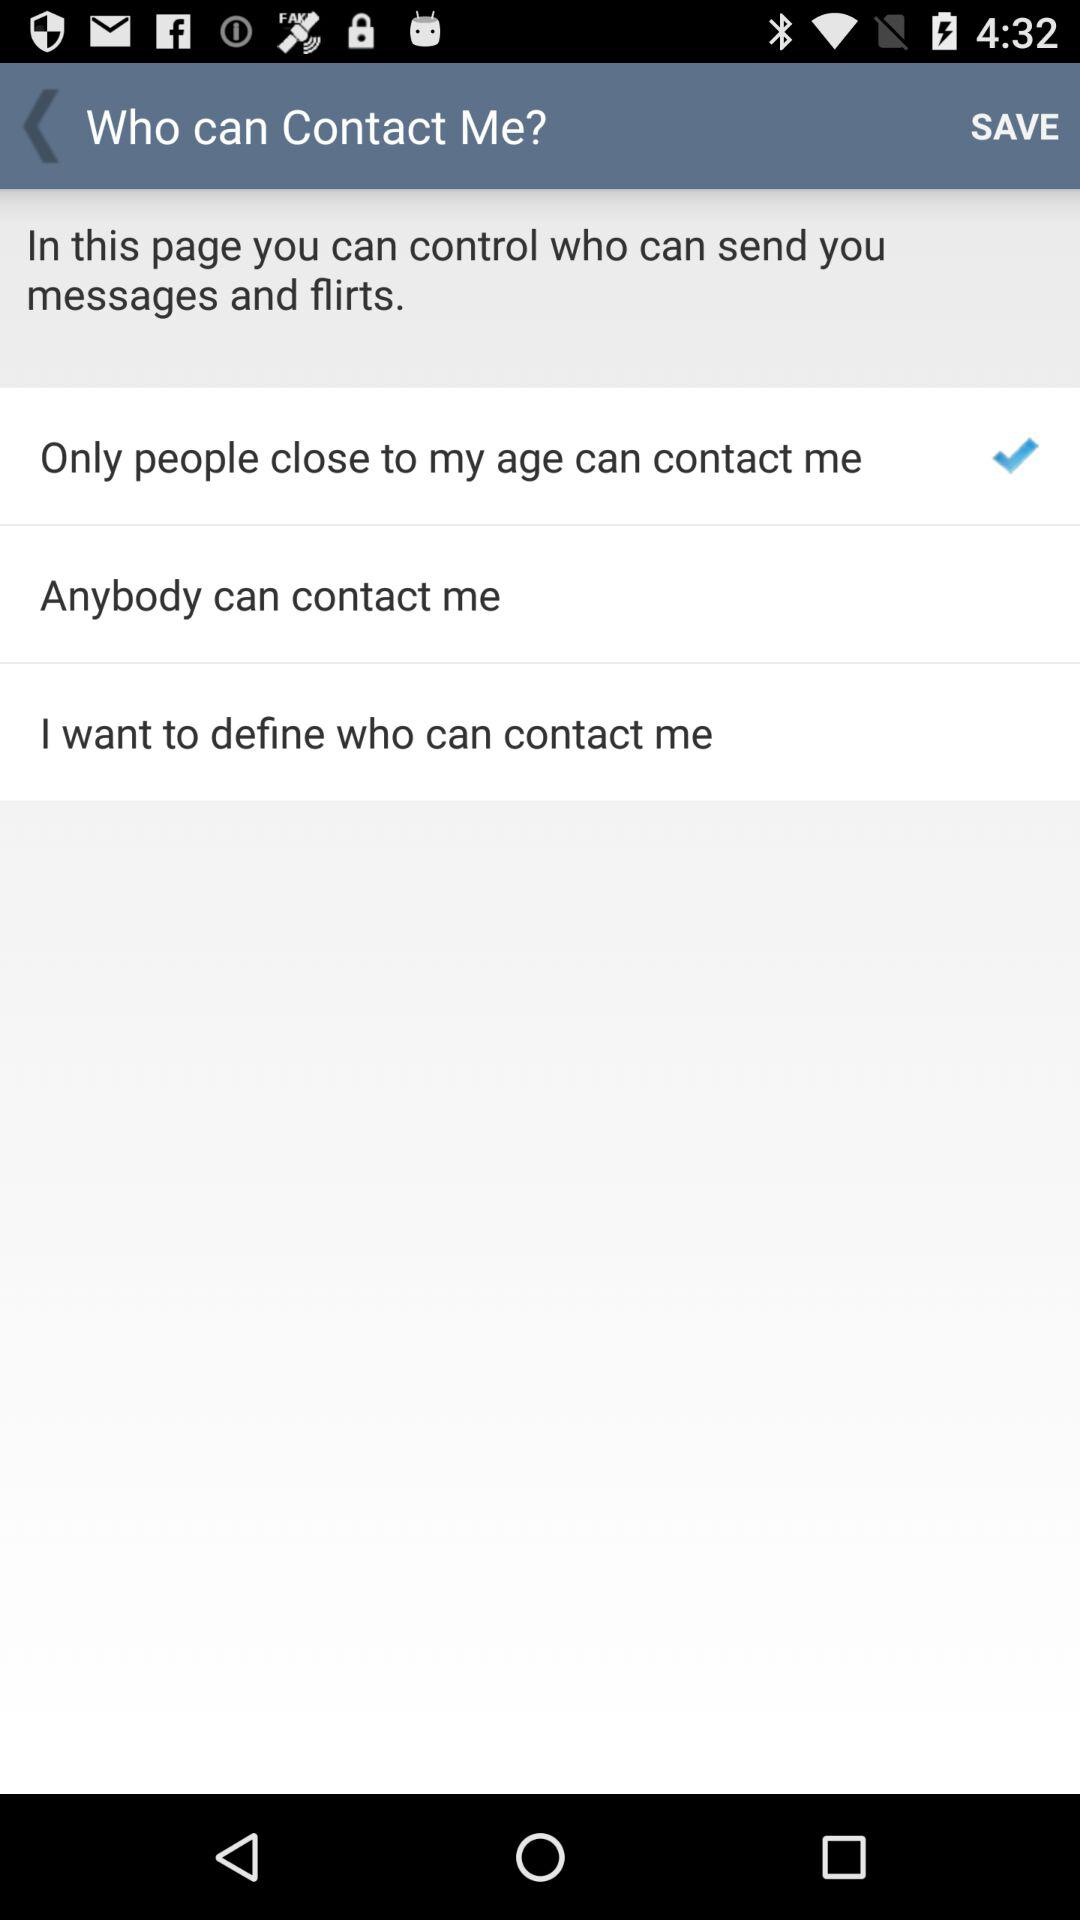How many options are there for who can contact me?
Answer the question using a single word or phrase. 3 